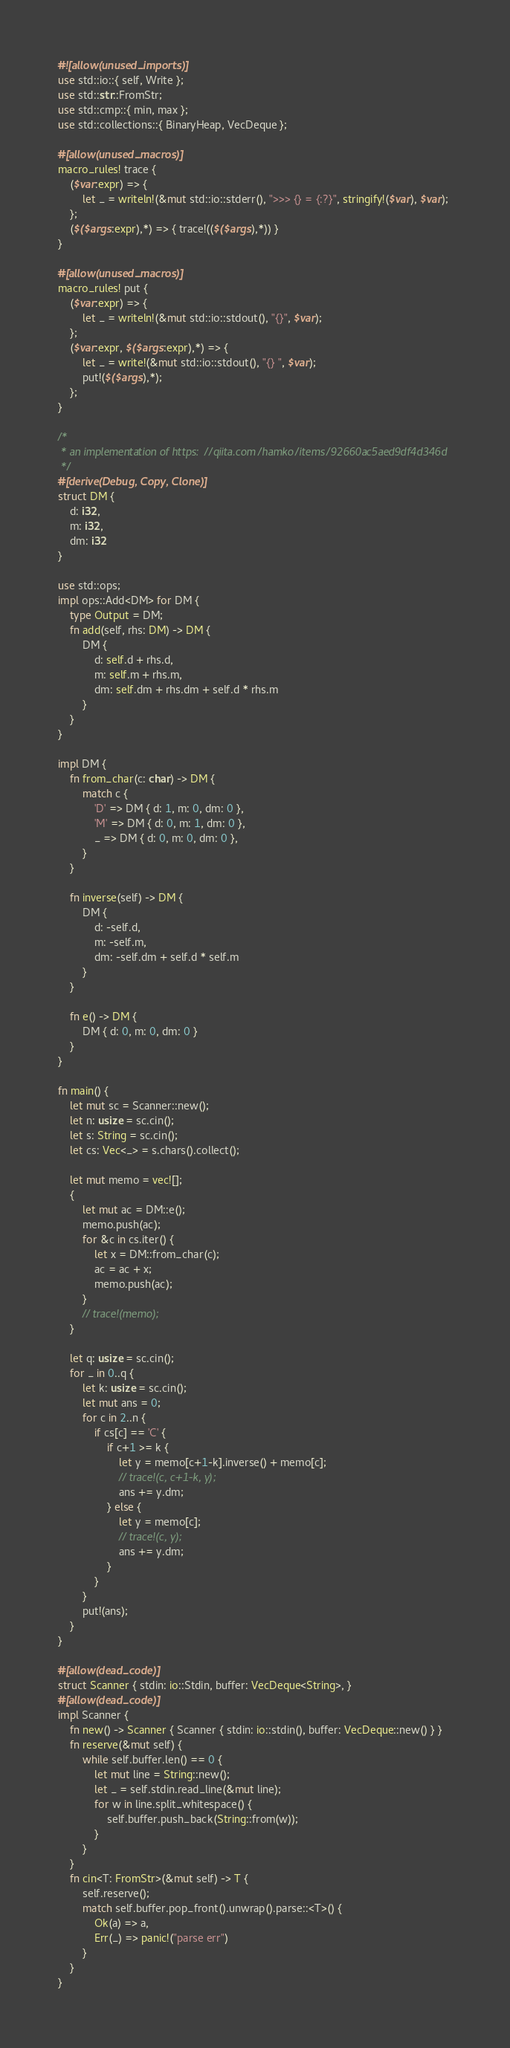Convert code to text. <code><loc_0><loc_0><loc_500><loc_500><_Rust_>#![allow(unused_imports)]
use std::io::{ self, Write };
use std::str::FromStr;
use std::cmp::{ min, max };
use std::collections::{ BinaryHeap, VecDeque };

#[allow(unused_macros)]
macro_rules! trace {
    ($var:expr) => {
        let _ = writeln!(&mut std::io::stderr(), ">>> {} = {:?}", stringify!($var), $var);
    };
    ($($args:expr),*) => { trace!(($($args),*)) }
}

#[allow(unused_macros)]
macro_rules! put {
    ($var:expr) => {
        let _ = writeln!(&mut std::io::stdout(), "{}", $var);
    };
    ($var:expr, $($args:expr),*) => {
        let _ = write!(&mut std::io::stdout(), "{} ", $var);
        put!($($args),*);
    };
}

/*
 * an implementation of https://qiita.com/hamko/items/92660ac5aed9df4d346d
 */
#[derive(Debug, Copy, Clone)]
struct DM {
    d: i32,
    m: i32,
    dm: i32
}

use std::ops;
impl ops::Add<DM> for DM {
    type Output = DM;
    fn add(self, rhs: DM) -> DM {
        DM {
            d: self.d + rhs.d,
            m: self.m + rhs.m,
            dm: self.dm + rhs.dm + self.d * rhs.m
        }
    }
}

impl DM {
    fn from_char(c: char) -> DM {
        match c {
            'D' => DM { d: 1, m: 0, dm: 0 },
            'M' => DM { d: 0, m: 1, dm: 0 },
            _ => DM { d: 0, m: 0, dm: 0 },
        }
    }

    fn inverse(self) -> DM {
        DM {
            d: -self.d,
            m: -self.m,
            dm: -self.dm + self.d * self.m
        }
    }

    fn e() -> DM {
        DM { d: 0, m: 0, dm: 0 }
    }
}

fn main() {
    let mut sc = Scanner::new();
    let n: usize = sc.cin();
    let s: String = sc.cin();
    let cs: Vec<_> = s.chars().collect();

    let mut memo = vec![];
    {
        let mut ac = DM::e();
        memo.push(ac);
        for &c in cs.iter() {
            let x = DM::from_char(c);
            ac = ac + x;
            memo.push(ac);
        }
        // trace!(memo);
    }

    let q: usize = sc.cin();
    for _ in 0..q {
        let k: usize = sc.cin();
        let mut ans = 0;
        for c in 2..n {
            if cs[c] == 'C' {
                if c+1 >= k {
                    let y = memo[c+1-k].inverse() + memo[c];
                    // trace!(c, c+1-k, y);
                    ans += y.dm;
                } else {
                    let y = memo[c];
                    // trace!(c, y);
                    ans += y.dm;
                }
            }
        }
        put!(ans);
    }
}

#[allow(dead_code)]
struct Scanner { stdin: io::Stdin, buffer: VecDeque<String>, }
#[allow(dead_code)]
impl Scanner {
    fn new() -> Scanner { Scanner { stdin: io::stdin(), buffer: VecDeque::new() } }
    fn reserve(&mut self) {
        while self.buffer.len() == 0 {
            let mut line = String::new();
            let _ = self.stdin.read_line(&mut line);
            for w in line.split_whitespace() {
                self.buffer.push_back(String::from(w));
            }
        }
    }
    fn cin<T: FromStr>(&mut self) -> T {
        self.reserve();
        match self.buffer.pop_front().unwrap().parse::<T>() {
            Ok(a) => a,
            Err(_) => panic!("parse err")
        }
    }
}
</code> 